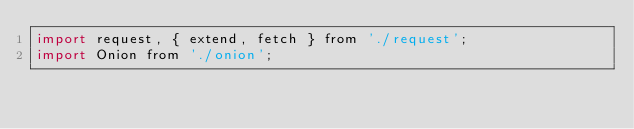<code> <loc_0><loc_0><loc_500><loc_500><_JavaScript_>import request, { extend, fetch } from './request';
import Onion from './onion';</code> 